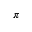Convert formula to latex. <formula><loc_0><loc_0><loc_500><loc_500>\pi</formula> 